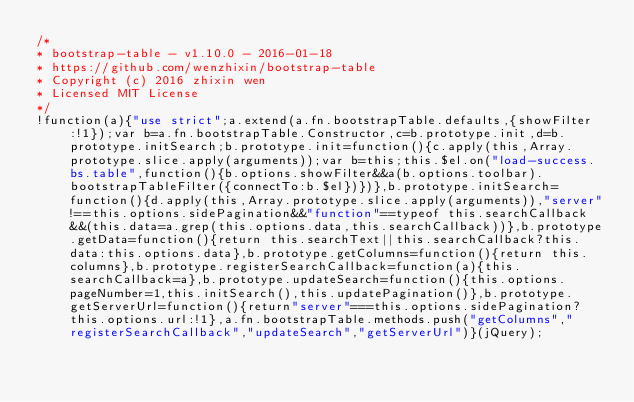Convert code to text. <code><loc_0><loc_0><loc_500><loc_500><_JavaScript_>/*
* bootstrap-table - v1.10.0 - 2016-01-18
* https://github.com/wenzhixin/bootstrap-table
* Copyright (c) 2016 zhixin wen
* Licensed MIT License
*/
!function(a){"use strict";a.extend(a.fn.bootstrapTable.defaults,{showFilter:!1});var b=a.fn.bootstrapTable.Constructor,c=b.prototype.init,d=b.prototype.initSearch;b.prototype.init=function(){c.apply(this,Array.prototype.slice.apply(arguments));var b=this;this.$el.on("load-success.bs.table",function(){b.options.showFilter&&a(b.options.toolbar).bootstrapTableFilter({connectTo:b.$el})})},b.prototype.initSearch=function(){d.apply(this,Array.prototype.slice.apply(arguments)),"server"!==this.options.sidePagination&&"function"==typeof this.searchCallback&&(this.data=a.grep(this.options.data,this.searchCallback))},b.prototype.getData=function(){return this.searchText||this.searchCallback?this.data:this.options.data},b.prototype.getColumns=function(){return this.columns},b.prototype.registerSearchCallback=function(a){this.searchCallback=a},b.prototype.updateSearch=function(){this.options.pageNumber=1,this.initSearch(),this.updatePagination()},b.prototype.getServerUrl=function(){return"server"===this.options.sidePagination?this.options.url:!1},a.fn.bootstrapTable.methods.push("getColumns","registerSearchCallback","updateSearch","getServerUrl")}(jQuery);</code> 